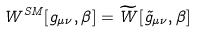Convert formula to latex. <formula><loc_0><loc_0><loc_500><loc_500>W ^ { S M } [ g _ { \mu \nu } , \beta ] = \widetilde { W } [ \tilde { g } _ { \mu \nu } , \beta ]</formula> 